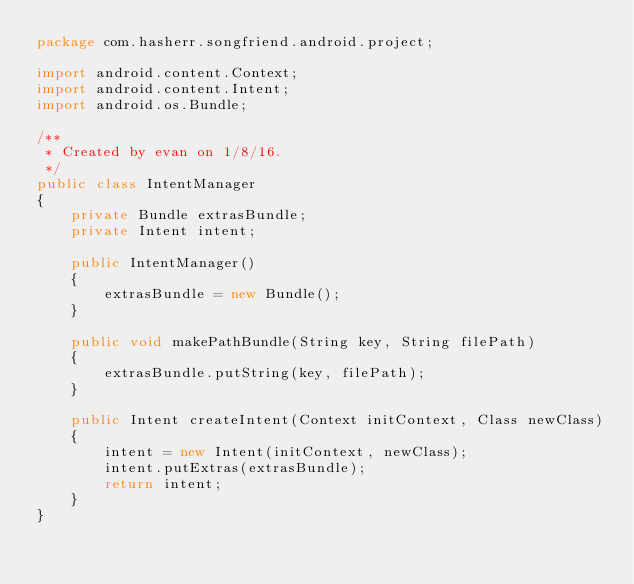<code> <loc_0><loc_0><loc_500><loc_500><_Java_>package com.hasherr.songfriend.android.project;

import android.content.Context;
import android.content.Intent;
import android.os.Bundle;

/**
 * Created by evan on 1/8/16.
 */
public class IntentManager
{
    private Bundle extrasBundle;
    private Intent intent;

    public IntentManager()
    {
        extrasBundle = new Bundle();
    }

    public void makePathBundle(String key, String filePath)
    {
        extrasBundle.putString(key, filePath);
    }

    public Intent createIntent(Context initContext, Class newClass)
    {
        intent = new Intent(initContext, newClass);
        intent.putExtras(extrasBundle);
        return intent;
    }
}</code> 